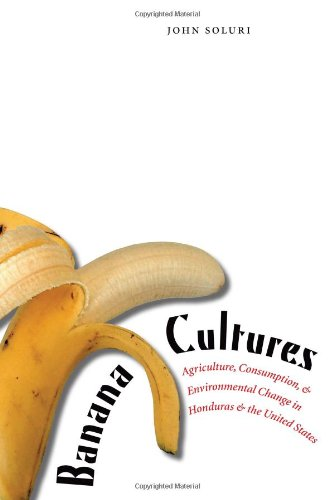What is the genre of this book? The genre of this insightful book is history, focusing specifically on socio-economic and environmental changes in agricultural sectors. 